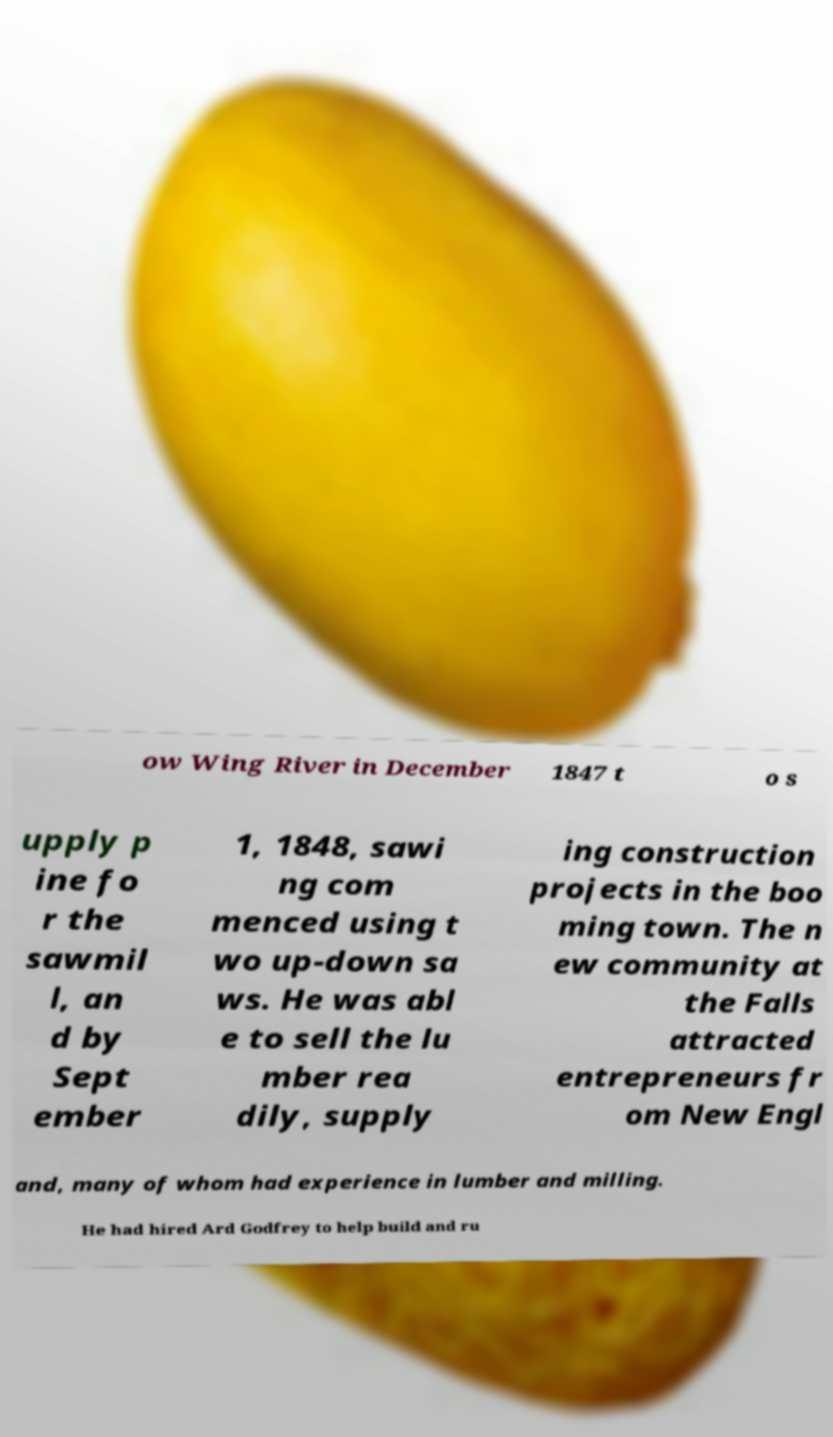Please read and relay the text visible in this image. What does it say? ow Wing River in December 1847 t o s upply p ine fo r the sawmil l, an d by Sept ember 1, 1848, sawi ng com menced using t wo up-down sa ws. He was abl e to sell the lu mber rea dily, supply ing construction projects in the boo ming town. The n ew community at the Falls attracted entrepreneurs fr om New Engl and, many of whom had experience in lumber and milling. He had hired Ard Godfrey to help build and ru 